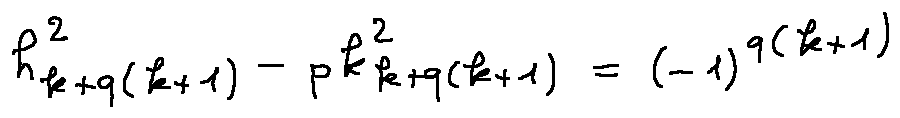<formula> <loc_0><loc_0><loc_500><loc_500>h _ { k + q ( k + 1 ) } ^ { 2 } - p k _ { k + q ( k + 1 ) } ^ { 2 } = ( - 1 ) ^ { q ( k + 1 ) }</formula> 